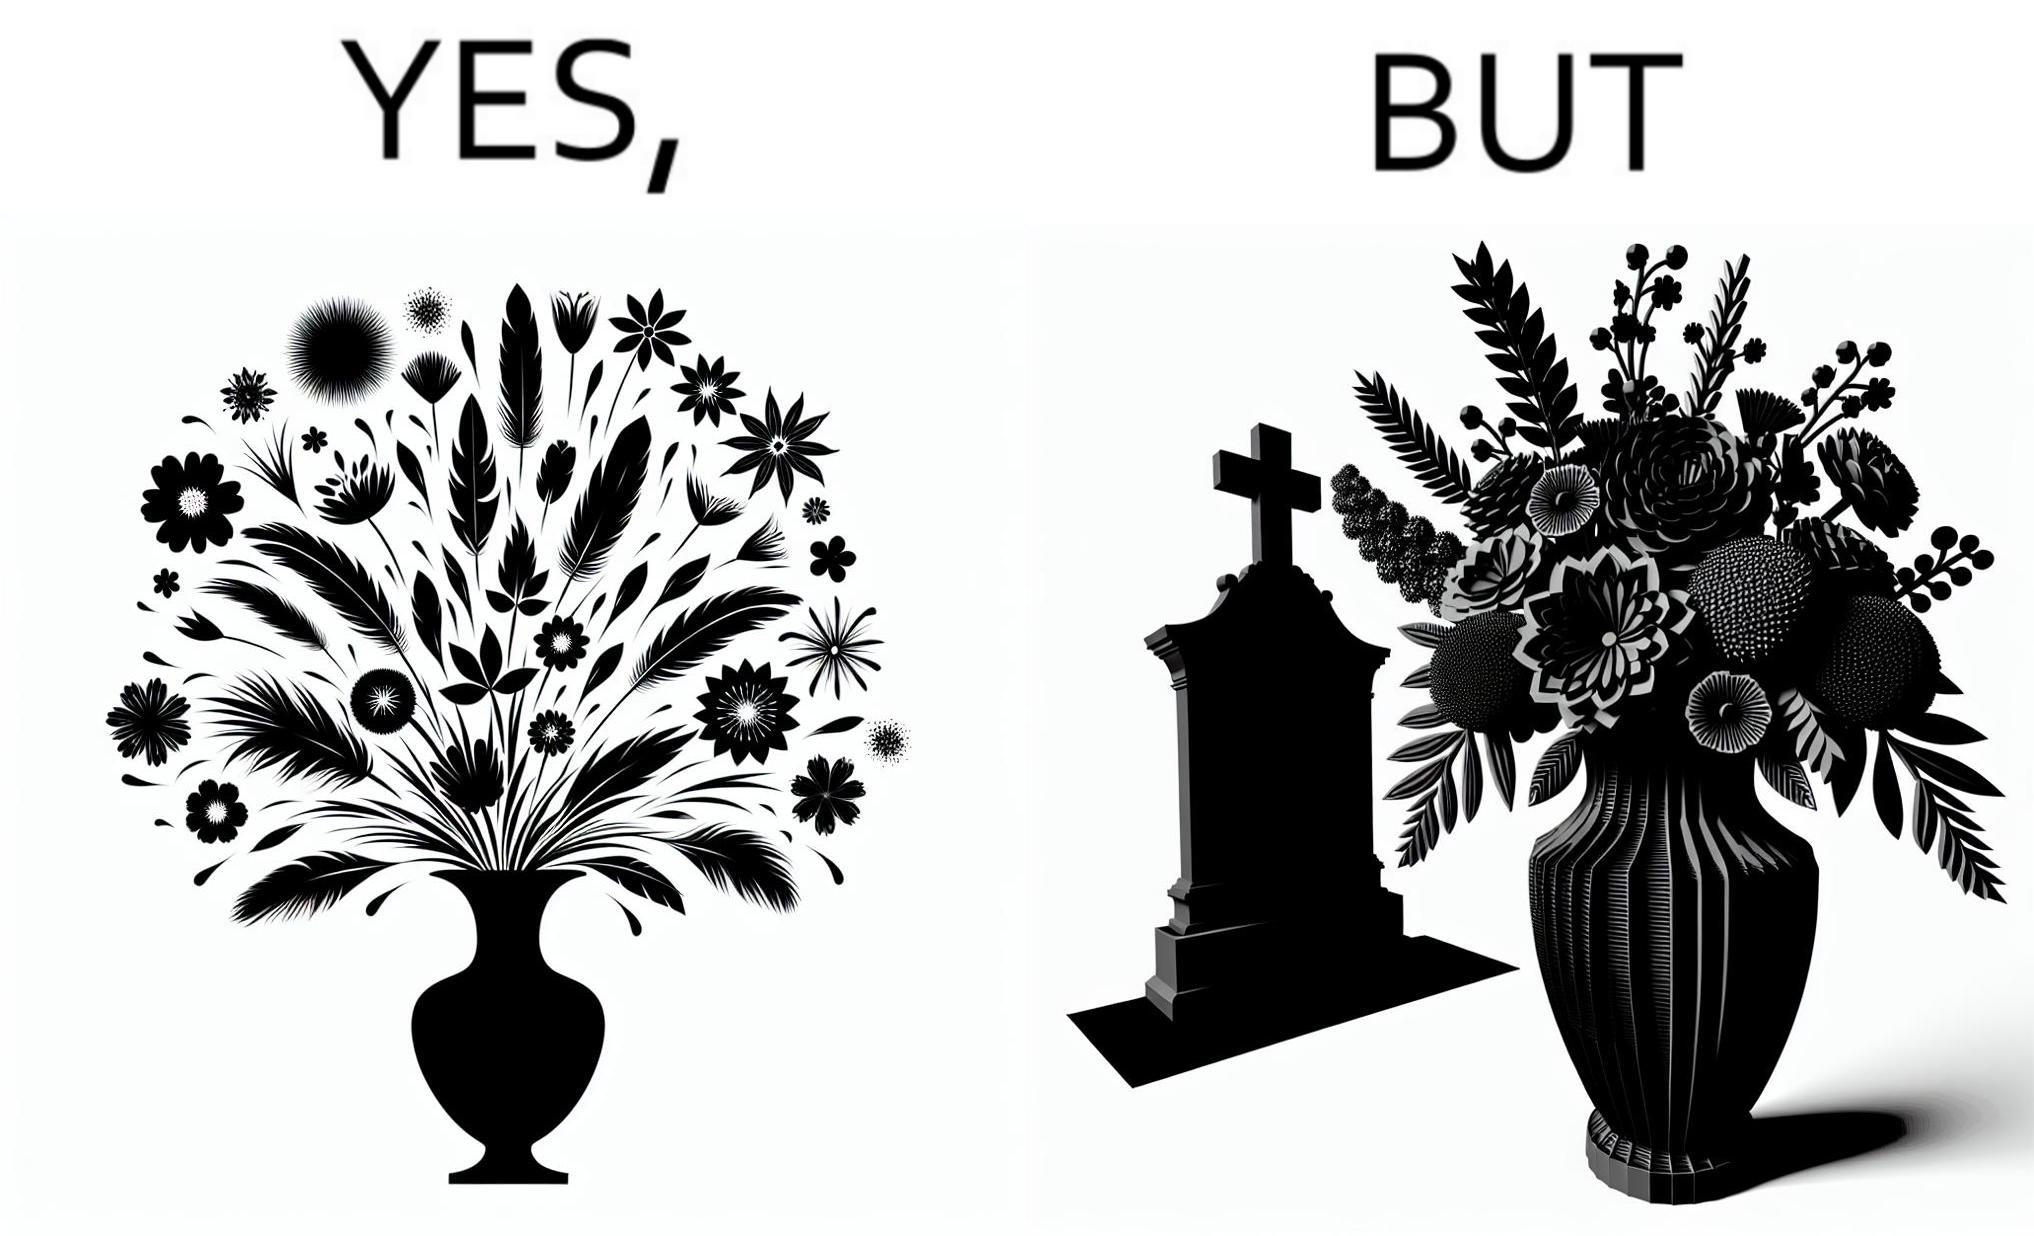Why is this image considered satirical? The image is ironic, because in the first image a vase full of different beautiful flowers is seen which spreads a feeling of positivity, cheerfulness etc., whereas in the second image when the same vase is put in front of a grave stone it produces a feeling of sorrow 